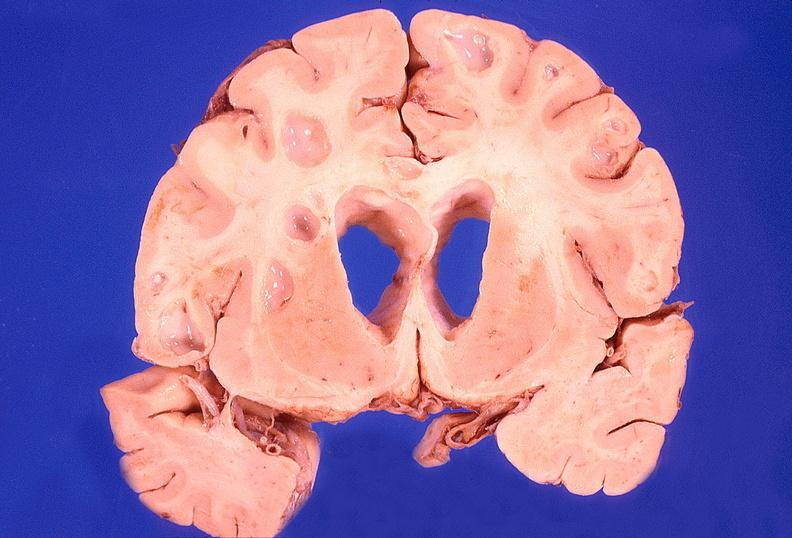s this image present?
Answer the question using a single word or phrase. No 